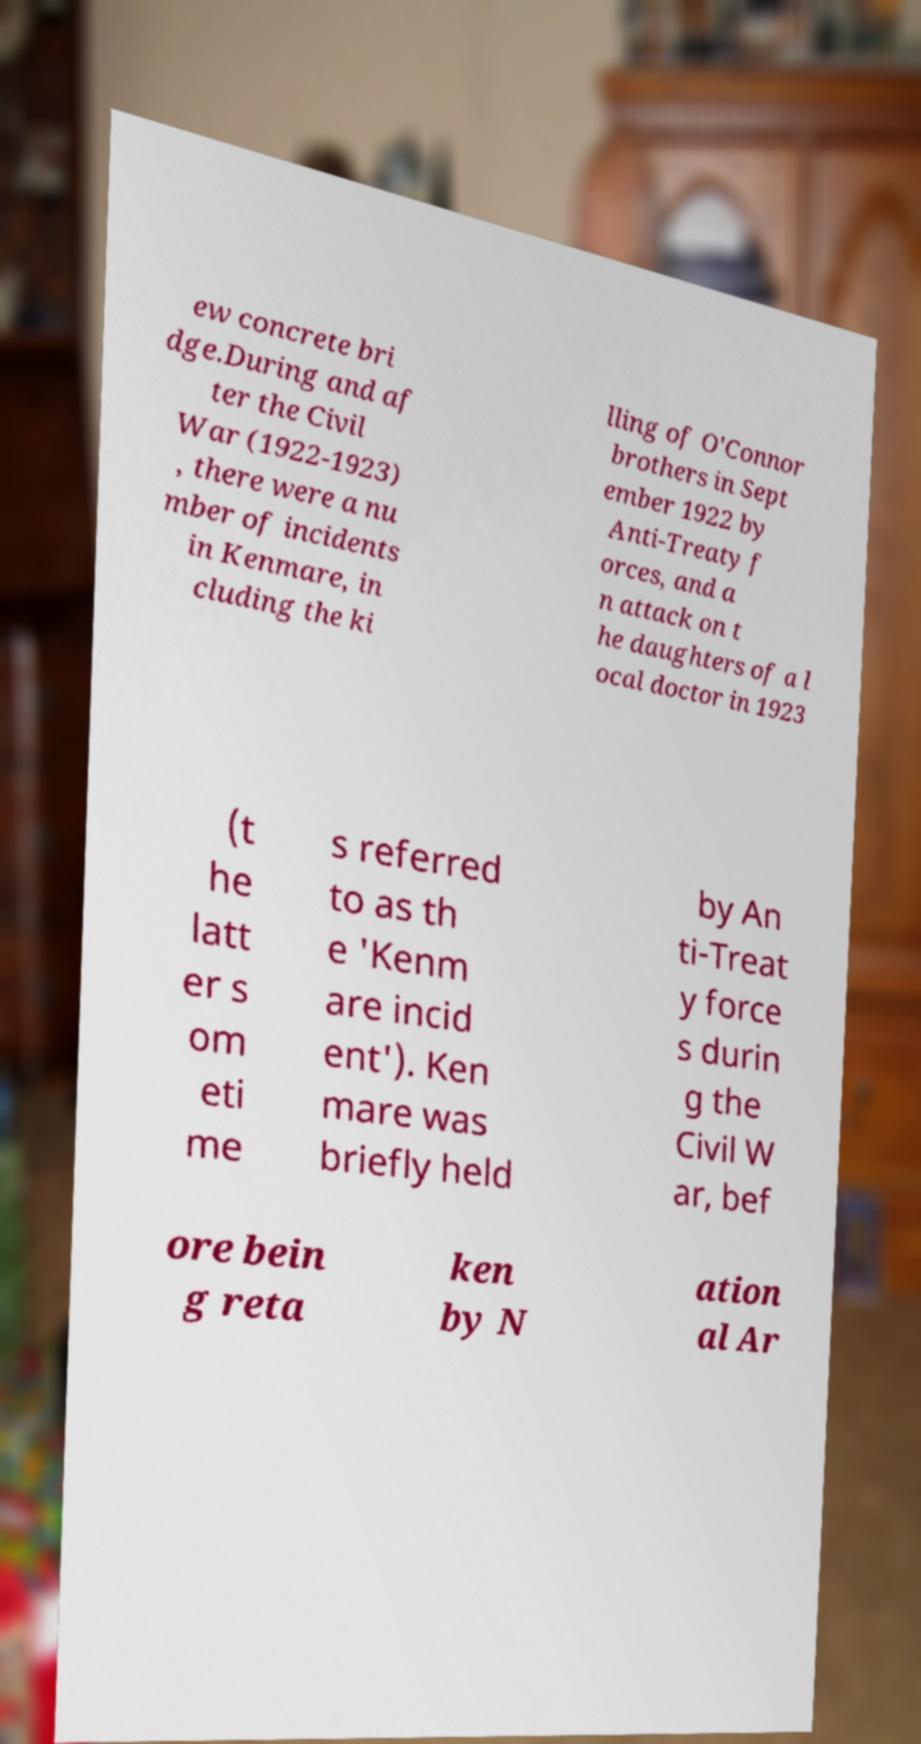Can you read and provide the text displayed in the image?This photo seems to have some interesting text. Can you extract and type it out for me? ew concrete bri dge.During and af ter the Civil War (1922-1923) , there were a nu mber of incidents in Kenmare, in cluding the ki lling of O'Connor brothers in Sept ember 1922 by Anti-Treaty f orces, and a n attack on t he daughters of a l ocal doctor in 1923 (t he latt er s om eti me s referred to as th e 'Kenm are incid ent'). Ken mare was briefly held by An ti-Treat y force s durin g the Civil W ar, bef ore bein g reta ken by N ation al Ar 